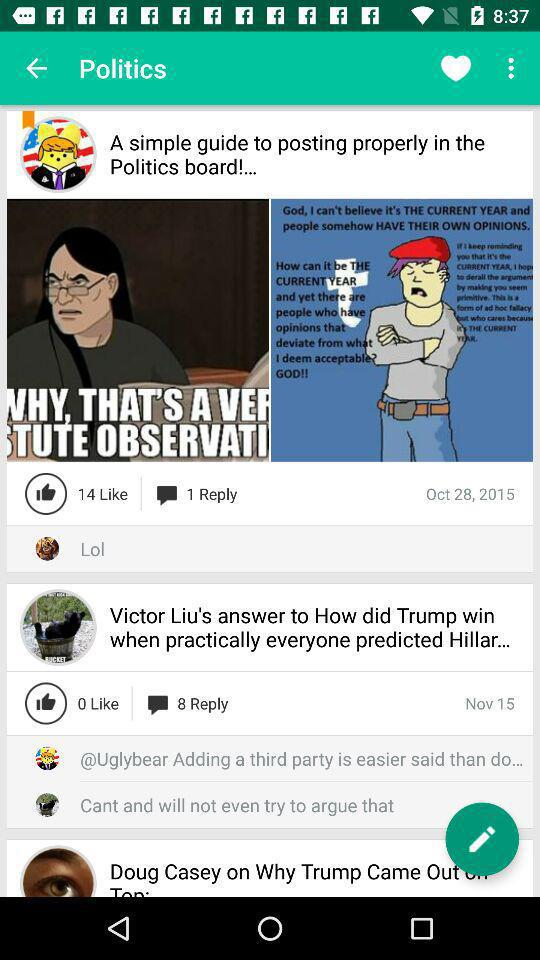How many likes are there on the post "A simple guide to posting properly in the Politics board"? The post "A simple guide to posting properly in the Politics board" has 14 likes. 